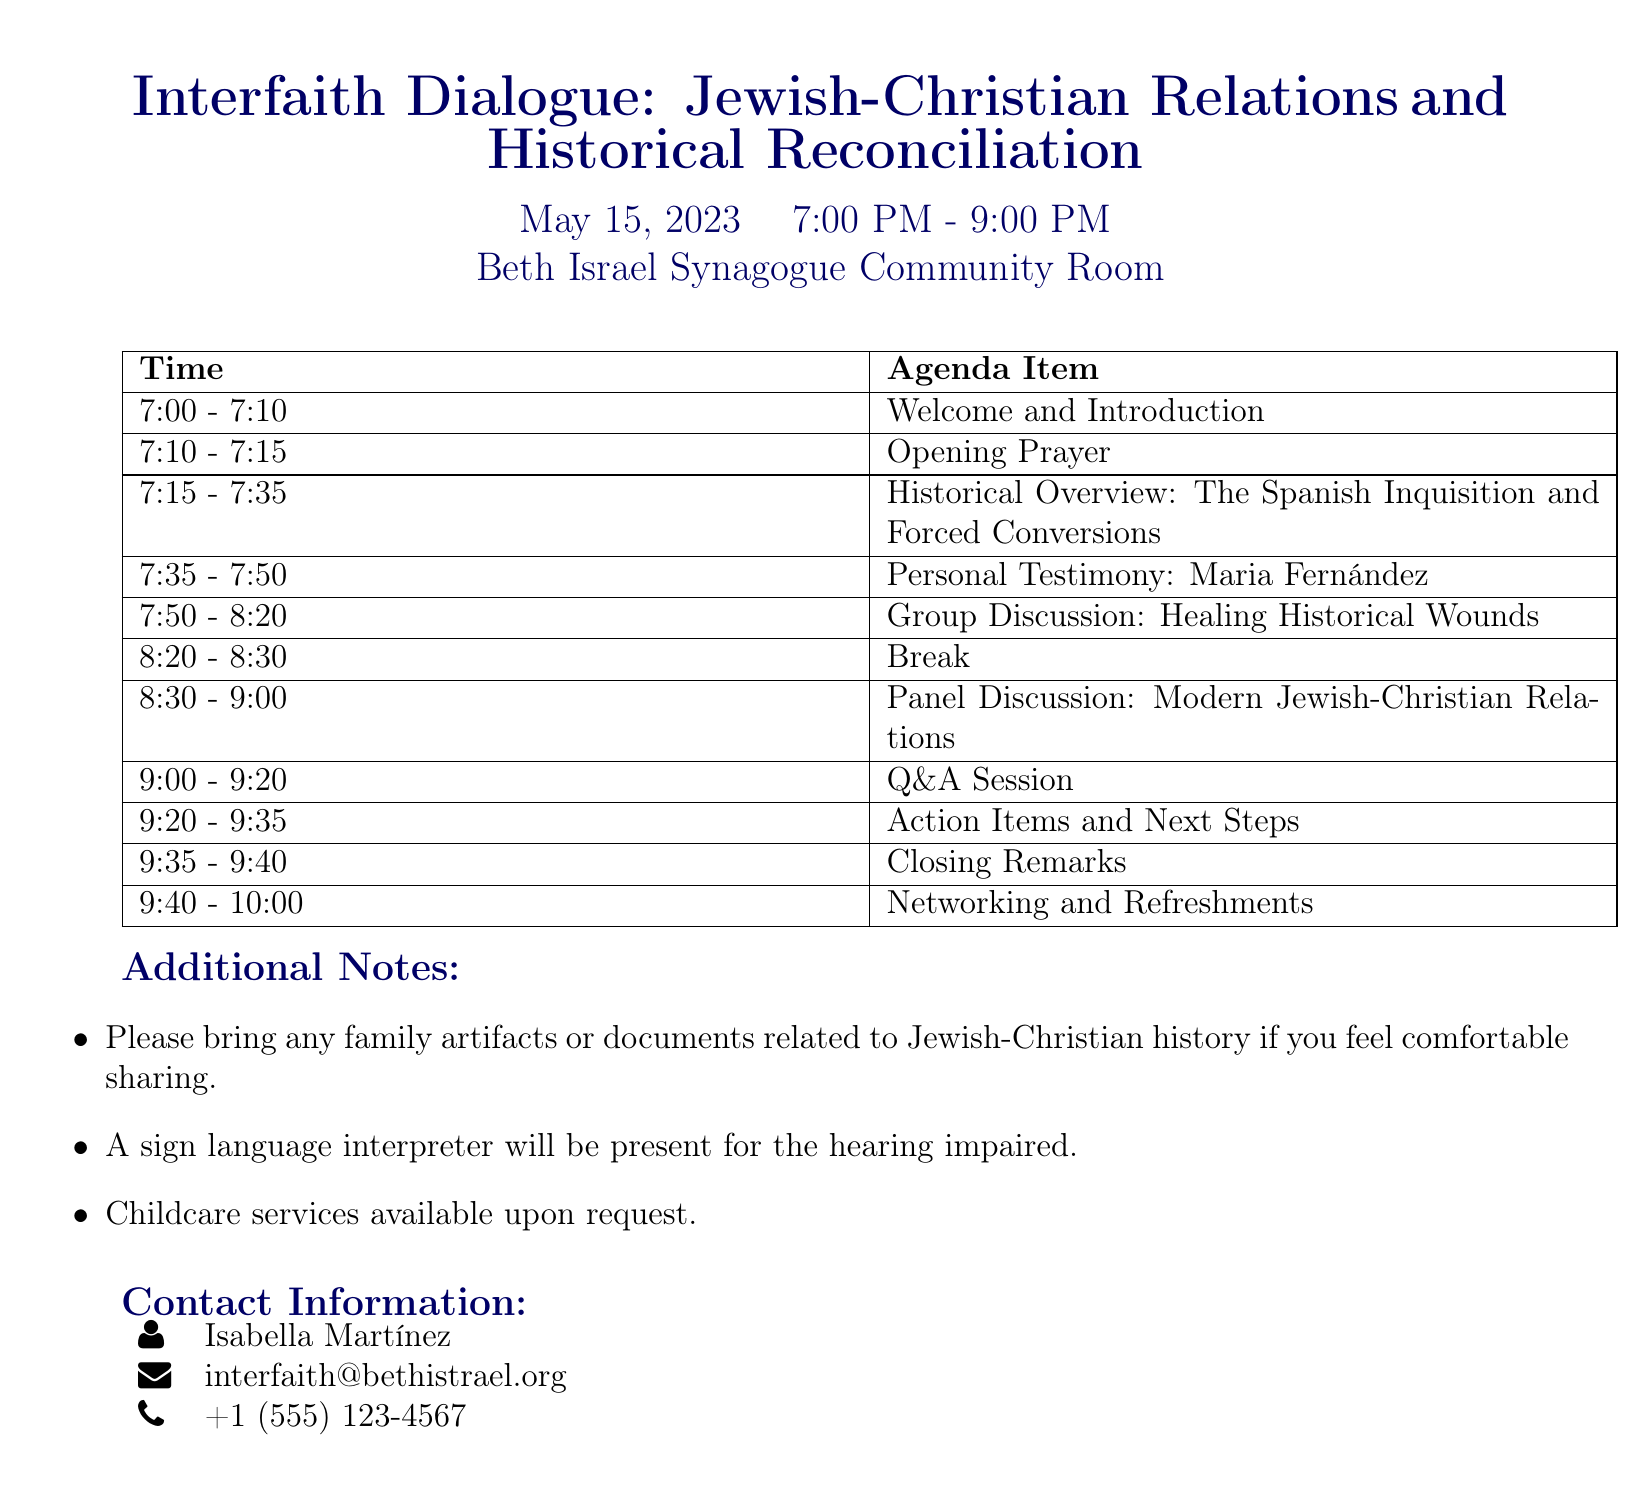What is the date of the meeting? The date is listed in the document under the title section, which indicates when the event will take place.
Answer: May 15, 2023 Who is the speaker for the historical overview? The document specifies who will present various sections, including the historical overview, identifying the speaker.
Answer: Dr. Elena Rodríguez What is the duration of the panel discussion? The agenda outlines the time allocated for each item, which helps to plan attendance accordingly.
Answer: 30 minutes What topics will be discussed in the group discussion? The document provides a list of topics that will be covered during the group discussion, outlining key points of focus.
Answer: Acknowledging past injustices, Steps towards reconciliation, Role of faith communities in healing Is there childcare available for attendees? The additional notes section mentions services available during the meeting, including childcare arrangements.
Answer: Yes What time does the networking and refreshments segment start? The agenda includes specific timings for each segment of the meeting, revealing when informal discussions begin.
Answer: 9:40 PM Who will lead the opening prayer? The document lists who will conduct various segments of the meeting, including the opening prayer.
Answer: Cantor David Levy How long is the break scheduled for? The agenda specifies a time allotted for breaks, which is essential for attendees to plan their participation.
Answer: 10 minutes 